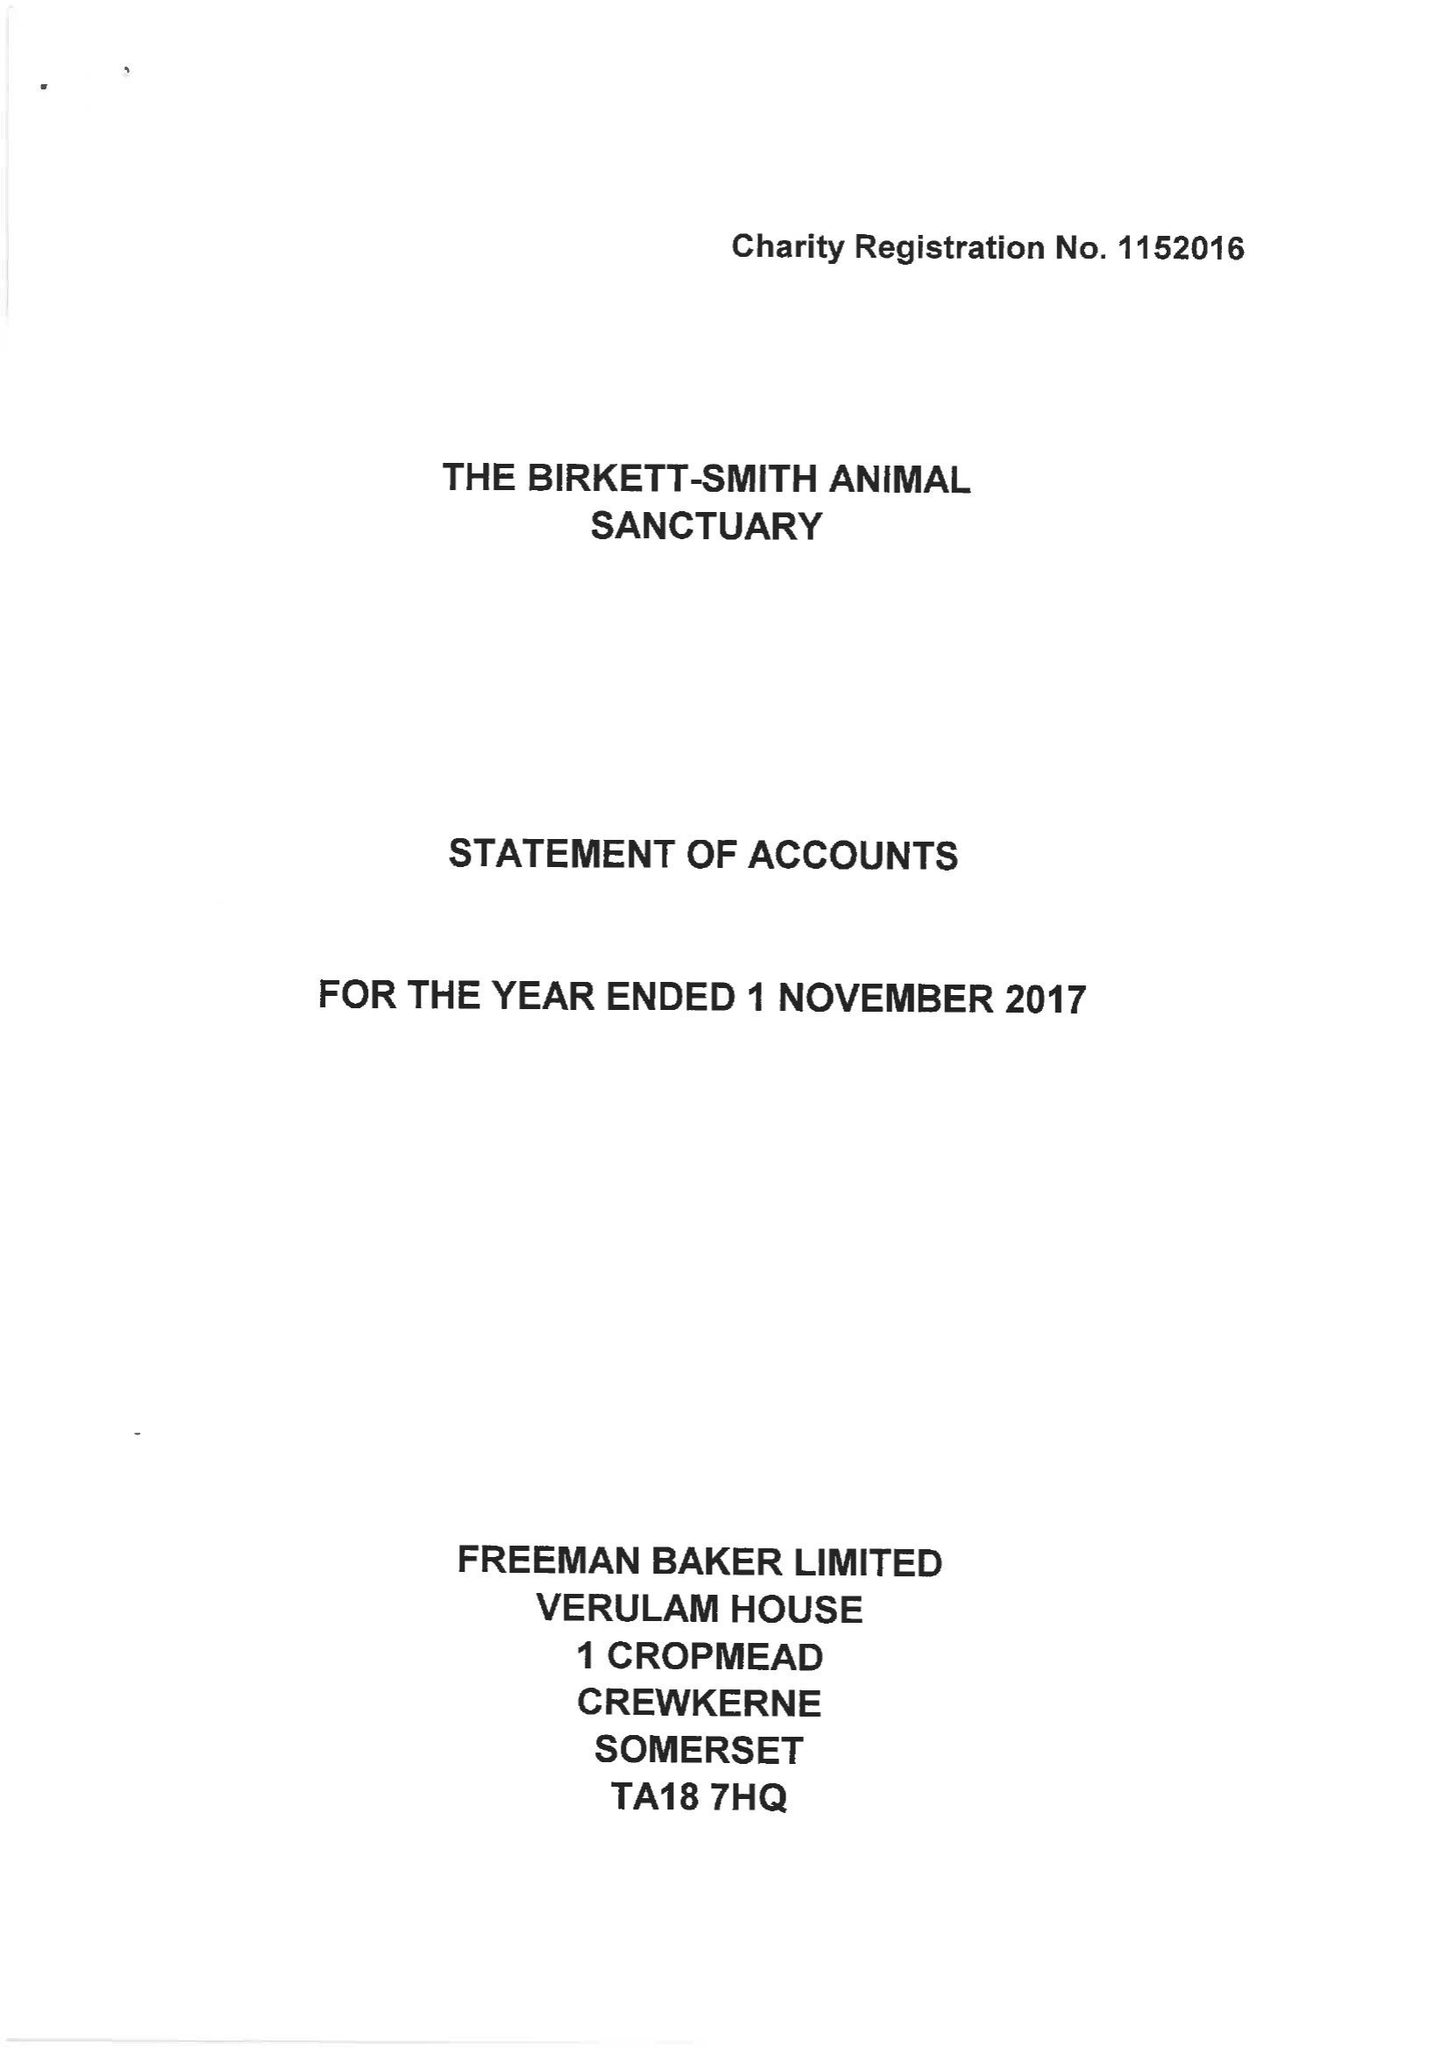What is the value for the charity_number?
Answer the question using a single word or phrase. 1152016 